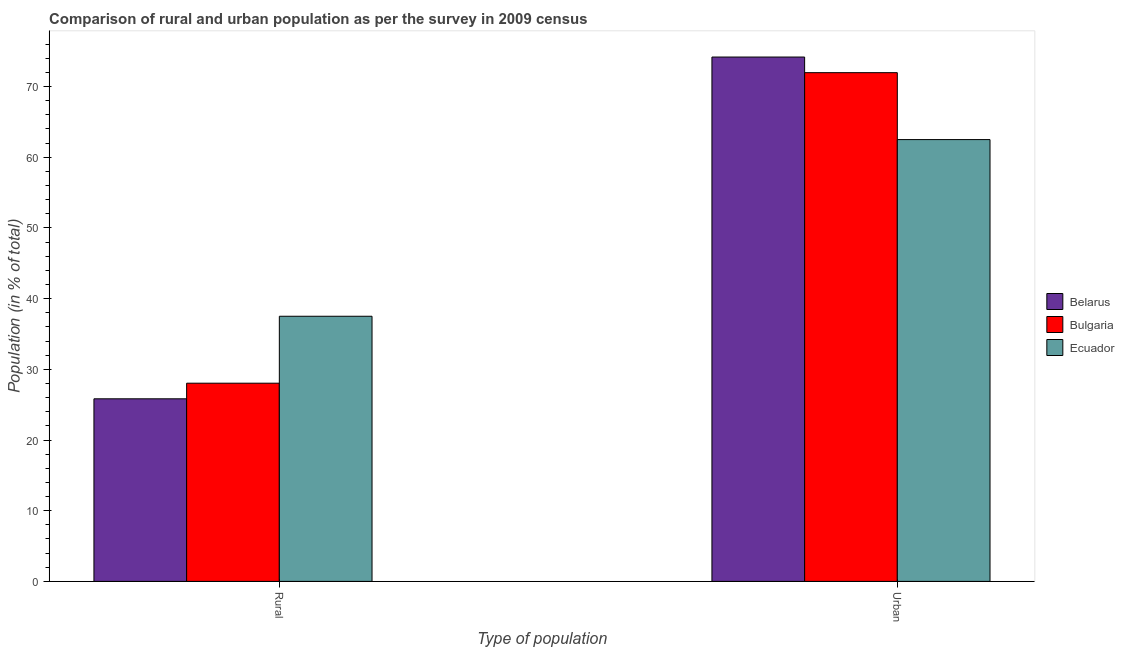How many groups of bars are there?
Offer a terse response. 2. Are the number of bars per tick equal to the number of legend labels?
Your response must be concise. Yes. Are the number of bars on each tick of the X-axis equal?
Offer a very short reply. Yes. What is the label of the 1st group of bars from the left?
Provide a short and direct response. Rural. What is the urban population in Belarus?
Ensure brevity in your answer.  74.17. Across all countries, what is the maximum rural population?
Provide a short and direct response. 37.51. Across all countries, what is the minimum rural population?
Your response must be concise. 25.83. In which country was the rural population maximum?
Your answer should be very brief. Ecuador. In which country was the urban population minimum?
Offer a very short reply. Ecuador. What is the total urban population in the graph?
Your response must be concise. 208.63. What is the difference between the rural population in Belarus and that in Ecuador?
Give a very brief answer. -11.68. What is the difference between the rural population in Ecuador and the urban population in Bulgaria?
Provide a short and direct response. -34.46. What is the average urban population per country?
Offer a terse response. 69.54. What is the difference between the urban population and rural population in Belarus?
Make the answer very short. 48.34. What is the ratio of the urban population in Belarus to that in Ecuador?
Provide a succinct answer. 1.19. Is the rural population in Ecuador less than that in Bulgaria?
Offer a very short reply. No. What does the 1st bar from the left in Urban represents?
Your response must be concise. Belarus. What does the 1st bar from the right in Urban represents?
Keep it short and to the point. Ecuador. How many countries are there in the graph?
Give a very brief answer. 3. Are the values on the major ticks of Y-axis written in scientific E-notation?
Keep it short and to the point. No. What is the title of the graph?
Make the answer very short. Comparison of rural and urban population as per the survey in 2009 census. Does "Europe(developing only)" appear as one of the legend labels in the graph?
Provide a succinct answer. No. What is the label or title of the X-axis?
Provide a short and direct response. Type of population. What is the label or title of the Y-axis?
Ensure brevity in your answer.  Population (in % of total). What is the Population (in % of total) in Belarus in Rural?
Your response must be concise. 25.83. What is the Population (in % of total) of Bulgaria in Rural?
Give a very brief answer. 28.04. What is the Population (in % of total) of Ecuador in Rural?
Offer a very short reply. 37.51. What is the Population (in % of total) in Belarus in Urban?
Your answer should be compact. 74.17. What is the Population (in % of total) in Bulgaria in Urban?
Your answer should be compact. 71.96. What is the Population (in % of total) in Ecuador in Urban?
Make the answer very short. 62.49. Across all Type of population, what is the maximum Population (in % of total) in Belarus?
Provide a succinct answer. 74.17. Across all Type of population, what is the maximum Population (in % of total) of Bulgaria?
Your response must be concise. 71.96. Across all Type of population, what is the maximum Population (in % of total) of Ecuador?
Keep it short and to the point. 62.49. Across all Type of population, what is the minimum Population (in % of total) in Belarus?
Make the answer very short. 25.83. Across all Type of population, what is the minimum Population (in % of total) of Bulgaria?
Offer a very short reply. 28.04. Across all Type of population, what is the minimum Population (in % of total) in Ecuador?
Your answer should be very brief. 37.51. What is the total Population (in % of total) in Bulgaria in the graph?
Provide a short and direct response. 100. What is the total Population (in % of total) of Ecuador in the graph?
Your answer should be compact. 100. What is the difference between the Population (in % of total) of Belarus in Rural and that in Urban?
Give a very brief answer. -48.34. What is the difference between the Population (in % of total) in Bulgaria in Rural and that in Urban?
Give a very brief answer. -43.93. What is the difference between the Population (in % of total) of Ecuador in Rural and that in Urban?
Offer a terse response. -24.99. What is the difference between the Population (in % of total) in Belarus in Rural and the Population (in % of total) in Bulgaria in Urban?
Your answer should be compact. -46.13. What is the difference between the Population (in % of total) of Belarus in Rural and the Population (in % of total) of Ecuador in Urban?
Give a very brief answer. -36.67. What is the difference between the Population (in % of total) in Bulgaria in Rural and the Population (in % of total) in Ecuador in Urban?
Make the answer very short. -34.46. What is the average Population (in % of total) of Belarus per Type of population?
Your answer should be compact. 50. What is the average Population (in % of total) of Bulgaria per Type of population?
Provide a succinct answer. 50. What is the average Population (in % of total) in Ecuador per Type of population?
Provide a succinct answer. 50. What is the difference between the Population (in % of total) in Belarus and Population (in % of total) in Bulgaria in Rural?
Ensure brevity in your answer.  -2.21. What is the difference between the Population (in % of total) in Belarus and Population (in % of total) in Ecuador in Rural?
Offer a very short reply. -11.68. What is the difference between the Population (in % of total) in Bulgaria and Population (in % of total) in Ecuador in Rural?
Your answer should be compact. -9.47. What is the difference between the Population (in % of total) of Belarus and Population (in % of total) of Bulgaria in Urban?
Give a very brief answer. 2.21. What is the difference between the Population (in % of total) of Belarus and Population (in % of total) of Ecuador in Urban?
Your answer should be very brief. 11.68. What is the difference between the Population (in % of total) of Bulgaria and Population (in % of total) of Ecuador in Urban?
Your response must be concise. 9.47. What is the ratio of the Population (in % of total) of Belarus in Rural to that in Urban?
Give a very brief answer. 0.35. What is the ratio of the Population (in % of total) in Bulgaria in Rural to that in Urban?
Your answer should be compact. 0.39. What is the ratio of the Population (in % of total) of Ecuador in Rural to that in Urban?
Your answer should be compact. 0.6. What is the difference between the highest and the second highest Population (in % of total) in Belarus?
Your answer should be compact. 48.34. What is the difference between the highest and the second highest Population (in % of total) in Bulgaria?
Provide a short and direct response. 43.93. What is the difference between the highest and the second highest Population (in % of total) of Ecuador?
Offer a terse response. 24.99. What is the difference between the highest and the lowest Population (in % of total) of Belarus?
Your response must be concise. 48.34. What is the difference between the highest and the lowest Population (in % of total) of Bulgaria?
Offer a very short reply. 43.93. What is the difference between the highest and the lowest Population (in % of total) of Ecuador?
Offer a terse response. 24.99. 